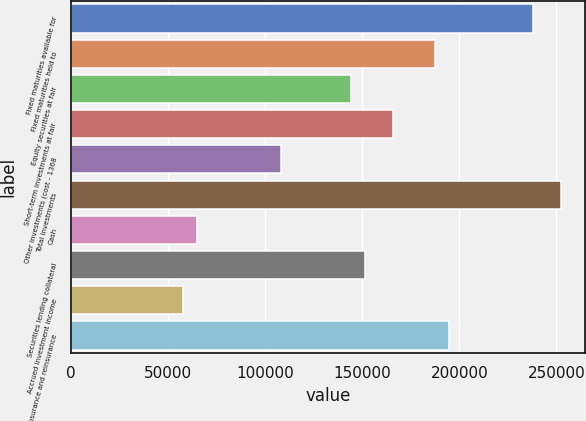Convert chart. <chart><loc_0><loc_0><loc_500><loc_500><bar_chart><fcel>Fixed maturities available for<fcel>Fixed maturities held to<fcel>Equity securities at fair<fcel>Short-term investments at fair<fcel>Other investments (cost - 1368<fcel>Total investments<fcel>Cash<fcel>Securities lending collateral<fcel>Accrued investment income<fcel>Insurance and reinsurance<nl><fcel>237890<fcel>187429<fcel>144177<fcel>165803<fcel>108134<fcel>252308<fcel>64881.3<fcel>151386<fcel>57672.6<fcel>194638<nl></chart> 